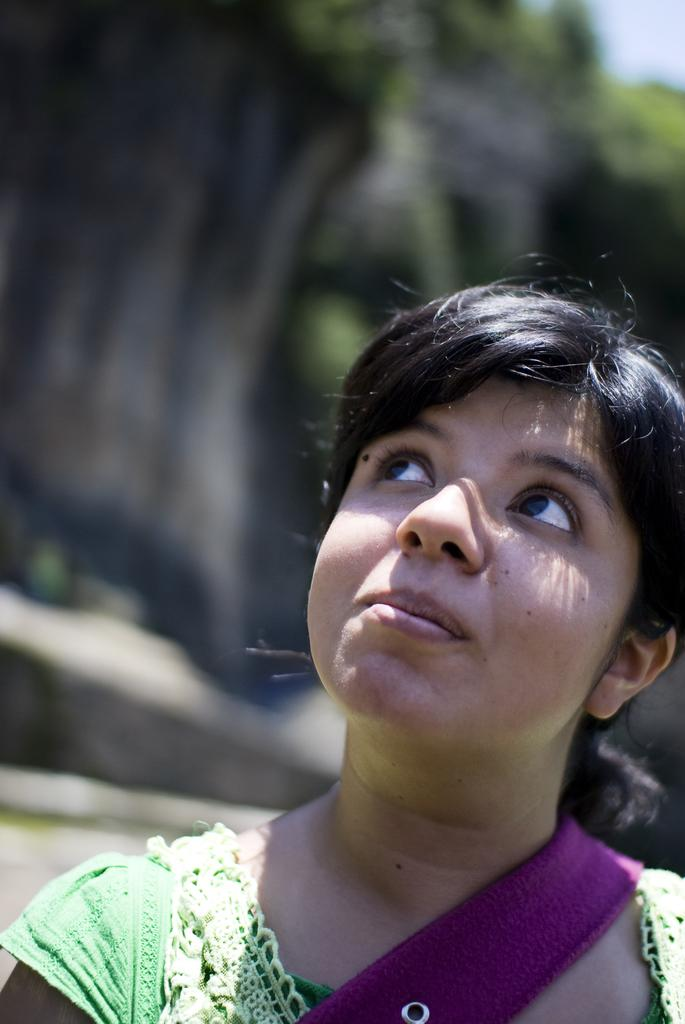Who is present in the image? There is a woman in the image. What is the woman wearing? The woman is wearing a green dress. What can be seen in the background of the image? There are trees in the background of the image. How would you describe the background of the image? The background of the image is blurred. How many nails are visible in the image? There are no nails present in the image. What is the value of the cent in the image? There is no cent present in the image. 